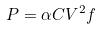Convert formula to latex. <formula><loc_0><loc_0><loc_500><loc_500>P = \alpha C V ^ { 2 } f</formula> 